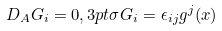Convert formula to latex. <formula><loc_0><loc_0><loc_500><loc_500>D _ { A } G _ { i } = 0 , 3 p t \sigma G _ { i } = \epsilon _ { i j } g ^ { j } ( x )</formula> 